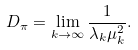Convert formula to latex. <formula><loc_0><loc_0><loc_500><loc_500>D _ { \pi } = \lim _ { k \to \infty } \frac { 1 } { \lambda _ { k } \mu _ { k } ^ { 2 } } .</formula> 